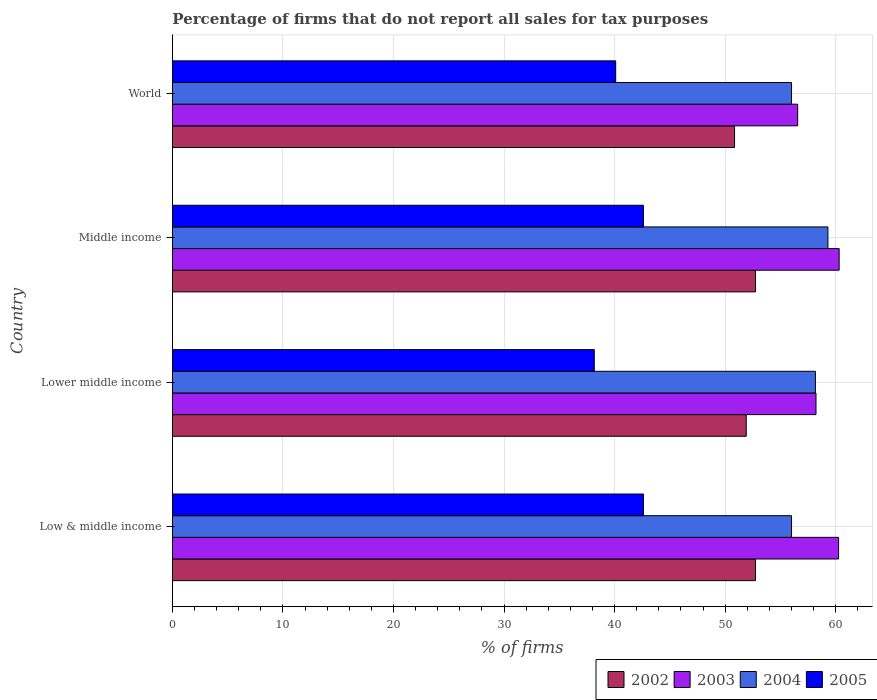How many different coloured bars are there?
Ensure brevity in your answer.  4. Are the number of bars per tick equal to the number of legend labels?
Your answer should be compact. Yes. Are the number of bars on each tick of the Y-axis equal?
Your answer should be very brief. Yes. How many bars are there on the 4th tick from the top?
Offer a very short reply. 4. How many bars are there on the 1st tick from the bottom?
Offer a terse response. 4. What is the label of the 2nd group of bars from the top?
Keep it short and to the point. Middle income. What is the percentage of firms that do not report all sales for tax purposes in 2003 in Low & middle income?
Ensure brevity in your answer.  60.26. Across all countries, what is the maximum percentage of firms that do not report all sales for tax purposes in 2003?
Offer a very short reply. 60.31. Across all countries, what is the minimum percentage of firms that do not report all sales for tax purposes in 2003?
Your response must be concise. 56.56. What is the total percentage of firms that do not report all sales for tax purposes in 2002 in the graph?
Ensure brevity in your answer.  208.25. What is the difference between the percentage of firms that do not report all sales for tax purposes in 2003 in Lower middle income and that in Middle income?
Offer a very short reply. -2.09. What is the difference between the percentage of firms that do not report all sales for tax purposes in 2003 in Middle income and the percentage of firms that do not report all sales for tax purposes in 2005 in Low & middle income?
Provide a short and direct response. 17.7. What is the average percentage of firms that do not report all sales for tax purposes in 2002 per country?
Your answer should be compact. 52.06. What is the difference between the percentage of firms that do not report all sales for tax purposes in 2002 and percentage of firms that do not report all sales for tax purposes in 2003 in World?
Your answer should be compact. -5.71. In how many countries, is the percentage of firms that do not report all sales for tax purposes in 2004 greater than 50 %?
Your answer should be very brief. 4. What is the ratio of the percentage of firms that do not report all sales for tax purposes in 2004 in Low & middle income to that in Lower middle income?
Make the answer very short. 0.96. Is the difference between the percentage of firms that do not report all sales for tax purposes in 2002 in Lower middle income and Middle income greater than the difference between the percentage of firms that do not report all sales for tax purposes in 2003 in Lower middle income and Middle income?
Ensure brevity in your answer.  Yes. What is the difference between the highest and the second highest percentage of firms that do not report all sales for tax purposes in 2004?
Give a very brief answer. 1.13. What is the difference between the highest and the lowest percentage of firms that do not report all sales for tax purposes in 2004?
Your answer should be very brief. 3.29. Is it the case that in every country, the sum of the percentage of firms that do not report all sales for tax purposes in 2003 and percentage of firms that do not report all sales for tax purposes in 2002 is greater than the sum of percentage of firms that do not report all sales for tax purposes in 2004 and percentage of firms that do not report all sales for tax purposes in 2005?
Offer a very short reply. No. What does the 2nd bar from the top in World represents?
Provide a short and direct response. 2004. Are all the bars in the graph horizontal?
Make the answer very short. Yes. What is the difference between two consecutive major ticks on the X-axis?
Your response must be concise. 10. Are the values on the major ticks of X-axis written in scientific E-notation?
Offer a terse response. No. Does the graph contain any zero values?
Provide a succinct answer. No. Does the graph contain grids?
Offer a terse response. Yes. Where does the legend appear in the graph?
Give a very brief answer. Bottom right. What is the title of the graph?
Ensure brevity in your answer.  Percentage of firms that do not report all sales for tax purposes. Does "1982" appear as one of the legend labels in the graph?
Your answer should be compact. No. What is the label or title of the X-axis?
Ensure brevity in your answer.  % of firms. What is the % of firms in 2002 in Low & middle income?
Make the answer very short. 52.75. What is the % of firms in 2003 in Low & middle income?
Your response must be concise. 60.26. What is the % of firms in 2004 in Low & middle income?
Your answer should be compact. 56.01. What is the % of firms of 2005 in Low & middle income?
Ensure brevity in your answer.  42.61. What is the % of firms of 2002 in Lower middle income?
Offer a very short reply. 51.91. What is the % of firms in 2003 in Lower middle income?
Offer a terse response. 58.22. What is the % of firms in 2004 in Lower middle income?
Offer a terse response. 58.16. What is the % of firms of 2005 in Lower middle income?
Provide a succinct answer. 38.16. What is the % of firms of 2002 in Middle income?
Keep it short and to the point. 52.75. What is the % of firms of 2003 in Middle income?
Your response must be concise. 60.31. What is the % of firms in 2004 in Middle income?
Your answer should be compact. 59.3. What is the % of firms of 2005 in Middle income?
Provide a short and direct response. 42.61. What is the % of firms in 2002 in World?
Make the answer very short. 50.85. What is the % of firms in 2003 in World?
Make the answer very short. 56.56. What is the % of firms in 2004 in World?
Provide a short and direct response. 56.01. What is the % of firms in 2005 in World?
Keep it short and to the point. 40.1. Across all countries, what is the maximum % of firms in 2002?
Offer a terse response. 52.75. Across all countries, what is the maximum % of firms of 2003?
Provide a short and direct response. 60.31. Across all countries, what is the maximum % of firms in 2004?
Offer a very short reply. 59.3. Across all countries, what is the maximum % of firms of 2005?
Ensure brevity in your answer.  42.61. Across all countries, what is the minimum % of firms of 2002?
Your answer should be compact. 50.85. Across all countries, what is the minimum % of firms of 2003?
Offer a very short reply. 56.56. Across all countries, what is the minimum % of firms of 2004?
Make the answer very short. 56.01. Across all countries, what is the minimum % of firms in 2005?
Offer a terse response. 38.16. What is the total % of firms of 2002 in the graph?
Ensure brevity in your answer.  208.25. What is the total % of firms in 2003 in the graph?
Your answer should be very brief. 235.35. What is the total % of firms in 2004 in the graph?
Offer a terse response. 229.47. What is the total % of firms in 2005 in the graph?
Keep it short and to the point. 163.48. What is the difference between the % of firms in 2002 in Low & middle income and that in Lower middle income?
Provide a short and direct response. 0.84. What is the difference between the % of firms of 2003 in Low & middle income and that in Lower middle income?
Offer a very short reply. 2.04. What is the difference between the % of firms in 2004 in Low & middle income and that in Lower middle income?
Provide a succinct answer. -2.16. What is the difference between the % of firms in 2005 in Low & middle income and that in Lower middle income?
Offer a very short reply. 4.45. What is the difference between the % of firms of 2002 in Low & middle income and that in Middle income?
Ensure brevity in your answer.  0. What is the difference between the % of firms in 2003 in Low & middle income and that in Middle income?
Your answer should be very brief. -0.05. What is the difference between the % of firms in 2004 in Low & middle income and that in Middle income?
Provide a succinct answer. -3.29. What is the difference between the % of firms in 2005 in Low & middle income and that in Middle income?
Your answer should be very brief. 0. What is the difference between the % of firms of 2002 in Low & middle income and that in World?
Your answer should be very brief. 1.89. What is the difference between the % of firms in 2005 in Low & middle income and that in World?
Ensure brevity in your answer.  2.51. What is the difference between the % of firms of 2002 in Lower middle income and that in Middle income?
Keep it short and to the point. -0.84. What is the difference between the % of firms in 2003 in Lower middle income and that in Middle income?
Your answer should be compact. -2.09. What is the difference between the % of firms in 2004 in Lower middle income and that in Middle income?
Ensure brevity in your answer.  -1.13. What is the difference between the % of firms of 2005 in Lower middle income and that in Middle income?
Provide a short and direct response. -4.45. What is the difference between the % of firms of 2002 in Lower middle income and that in World?
Your answer should be very brief. 1.06. What is the difference between the % of firms of 2003 in Lower middle income and that in World?
Provide a short and direct response. 1.66. What is the difference between the % of firms of 2004 in Lower middle income and that in World?
Your answer should be compact. 2.16. What is the difference between the % of firms of 2005 in Lower middle income and that in World?
Provide a succinct answer. -1.94. What is the difference between the % of firms of 2002 in Middle income and that in World?
Offer a terse response. 1.89. What is the difference between the % of firms of 2003 in Middle income and that in World?
Ensure brevity in your answer.  3.75. What is the difference between the % of firms in 2004 in Middle income and that in World?
Offer a very short reply. 3.29. What is the difference between the % of firms of 2005 in Middle income and that in World?
Offer a very short reply. 2.51. What is the difference between the % of firms in 2002 in Low & middle income and the % of firms in 2003 in Lower middle income?
Ensure brevity in your answer.  -5.47. What is the difference between the % of firms of 2002 in Low & middle income and the % of firms of 2004 in Lower middle income?
Offer a very short reply. -5.42. What is the difference between the % of firms of 2002 in Low & middle income and the % of firms of 2005 in Lower middle income?
Your answer should be very brief. 14.58. What is the difference between the % of firms in 2003 in Low & middle income and the % of firms in 2004 in Lower middle income?
Your answer should be compact. 2.1. What is the difference between the % of firms in 2003 in Low & middle income and the % of firms in 2005 in Lower middle income?
Provide a short and direct response. 22.1. What is the difference between the % of firms of 2004 in Low & middle income and the % of firms of 2005 in Lower middle income?
Your answer should be very brief. 17.84. What is the difference between the % of firms in 2002 in Low & middle income and the % of firms in 2003 in Middle income?
Offer a very short reply. -7.57. What is the difference between the % of firms in 2002 in Low & middle income and the % of firms in 2004 in Middle income?
Provide a succinct answer. -6.55. What is the difference between the % of firms in 2002 in Low & middle income and the % of firms in 2005 in Middle income?
Offer a terse response. 10.13. What is the difference between the % of firms in 2003 in Low & middle income and the % of firms in 2005 in Middle income?
Keep it short and to the point. 17.65. What is the difference between the % of firms in 2004 in Low & middle income and the % of firms in 2005 in Middle income?
Give a very brief answer. 13.39. What is the difference between the % of firms in 2002 in Low & middle income and the % of firms in 2003 in World?
Offer a terse response. -3.81. What is the difference between the % of firms of 2002 in Low & middle income and the % of firms of 2004 in World?
Your answer should be compact. -3.26. What is the difference between the % of firms in 2002 in Low & middle income and the % of firms in 2005 in World?
Your response must be concise. 12.65. What is the difference between the % of firms of 2003 in Low & middle income and the % of firms of 2004 in World?
Ensure brevity in your answer.  4.25. What is the difference between the % of firms in 2003 in Low & middle income and the % of firms in 2005 in World?
Offer a terse response. 20.16. What is the difference between the % of firms of 2004 in Low & middle income and the % of firms of 2005 in World?
Make the answer very short. 15.91. What is the difference between the % of firms of 2002 in Lower middle income and the % of firms of 2003 in Middle income?
Ensure brevity in your answer.  -8.4. What is the difference between the % of firms of 2002 in Lower middle income and the % of firms of 2004 in Middle income?
Your answer should be compact. -7.39. What is the difference between the % of firms of 2002 in Lower middle income and the % of firms of 2005 in Middle income?
Provide a succinct answer. 9.3. What is the difference between the % of firms in 2003 in Lower middle income and the % of firms in 2004 in Middle income?
Keep it short and to the point. -1.08. What is the difference between the % of firms in 2003 in Lower middle income and the % of firms in 2005 in Middle income?
Provide a short and direct response. 15.61. What is the difference between the % of firms of 2004 in Lower middle income and the % of firms of 2005 in Middle income?
Offer a very short reply. 15.55. What is the difference between the % of firms of 2002 in Lower middle income and the % of firms of 2003 in World?
Keep it short and to the point. -4.65. What is the difference between the % of firms in 2002 in Lower middle income and the % of firms in 2004 in World?
Ensure brevity in your answer.  -4.1. What is the difference between the % of firms in 2002 in Lower middle income and the % of firms in 2005 in World?
Offer a very short reply. 11.81. What is the difference between the % of firms of 2003 in Lower middle income and the % of firms of 2004 in World?
Your response must be concise. 2.21. What is the difference between the % of firms of 2003 in Lower middle income and the % of firms of 2005 in World?
Ensure brevity in your answer.  18.12. What is the difference between the % of firms in 2004 in Lower middle income and the % of firms in 2005 in World?
Offer a very short reply. 18.07. What is the difference between the % of firms in 2002 in Middle income and the % of firms in 2003 in World?
Offer a very short reply. -3.81. What is the difference between the % of firms in 2002 in Middle income and the % of firms in 2004 in World?
Give a very brief answer. -3.26. What is the difference between the % of firms in 2002 in Middle income and the % of firms in 2005 in World?
Give a very brief answer. 12.65. What is the difference between the % of firms of 2003 in Middle income and the % of firms of 2004 in World?
Your answer should be very brief. 4.31. What is the difference between the % of firms in 2003 in Middle income and the % of firms in 2005 in World?
Make the answer very short. 20.21. What is the difference between the % of firms of 2004 in Middle income and the % of firms of 2005 in World?
Your answer should be very brief. 19.2. What is the average % of firms of 2002 per country?
Provide a succinct answer. 52.06. What is the average % of firms in 2003 per country?
Offer a very short reply. 58.84. What is the average % of firms of 2004 per country?
Keep it short and to the point. 57.37. What is the average % of firms of 2005 per country?
Ensure brevity in your answer.  40.87. What is the difference between the % of firms of 2002 and % of firms of 2003 in Low & middle income?
Make the answer very short. -7.51. What is the difference between the % of firms of 2002 and % of firms of 2004 in Low & middle income?
Make the answer very short. -3.26. What is the difference between the % of firms of 2002 and % of firms of 2005 in Low & middle income?
Your response must be concise. 10.13. What is the difference between the % of firms of 2003 and % of firms of 2004 in Low & middle income?
Ensure brevity in your answer.  4.25. What is the difference between the % of firms of 2003 and % of firms of 2005 in Low & middle income?
Your response must be concise. 17.65. What is the difference between the % of firms in 2004 and % of firms in 2005 in Low & middle income?
Provide a short and direct response. 13.39. What is the difference between the % of firms of 2002 and % of firms of 2003 in Lower middle income?
Provide a succinct answer. -6.31. What is the difference between the % of firms of 2002 and % of firms of 2004 in Lower middle income?
Ensure brevity in your answer.  -6.26. What is the difference between the % of firms in 2002 and % of firms in 2005 in Lower middle income?
Provide a short and direct response. 13.75. What is the difference between the % of firms in 2003 and % of firms in 2004 in Lower middle income?
Offer a very short reply. 0.05. What is the difference between the % of firms in 2003 and % of firms in 2005 in Lower middle income?
Provide a short and direct response. 20.06. What is the difference between the % of firms of 2004 and % of firms of 2005 in Lower middle income?
Provide a succinct answer. 20. What is the difference between the % of firms in 2002 and % of firms in 2003 in Middle income?
Ensure brevity in your answer.  -7.57. What is the difference between the % of firms of 2002 and % of firms of 2004 in Middle income?
Make the answer very short. -6.55. What is the difference between the % of firms of 2002 and % of firms of 2005 in Middle income?
Ensure brevity in your answer.  10.13. What is the difference between the % of firms of 2003 and % of firms of 2004 in Middle income?
Provide a short and direct response. 1.02. What is the difference between the % of firms of 2003 and % of firms of 2005 in Middle income?
Keep it short and to the point. 17.7. What is the difference between the % of firms of 2004 and % of firms of 2005 in Middle income?
Make the answer very short. 16.69. What is the difference between the % of firms in 2002 and % of firms in 2003 in World?
Provide a succinct answer. -5.71. What is the difference between the % of firms of 2002 and % of firms of 2004 in World?
Your answer should be compact. -5.15. What is the difference between the % of firms in 2002 and % of firms in 2005 in World?
Provide a short and direct response. 10.75. What is the difference between the % of firms of 2003 and % of firms of 2004 in World?
Give a very brief answer. 0.56. What is the difference between the % of firms in 2003 and % of firms in 2005 in World?
Provide a short and direct response. 16.46. What is the difference between the % of firms of 2004 and % of firms of 2005 in World?
Keep it short and to the point. 15.91. What is the ratio of the % of firms in 2002 in Low & middle income to that in Lower middle income?
Offer a terse response. 1.02. What is the ratio of the % of firms of 2003 in Low & middle income to that in Lower middle income?
Your answer should be compact. 1.04. What is the ratio of the % of firms of 2004 in Low & middle income to that in Lower middle income?
Your response must be concise. 0.96. What is the ratio of the % of firms in 2005 in Low & middle income to that in Lower middle income?
Give a very brief answer. 1.12. What is the ratio of the % of firms of 2002 in Low & middle income to that in Middle income?
Keep it short and to the point. 1. What is the ratio of the % of firms in 2003 in Low & middle income to that in Middle income?
Ensure brevity in your answer.  1. What is the ratio of the % of firms of 2004 in Low & middle income to that in Middle income?
Your response must be concise. 0.94. What is the ratio of the % of firms in 2002 in Low & middle income to that in World?
Offer a terse response. 1.04. What is the ratio of the % of firms in 2003 in Low & middle income to that in World?
Provide a short and direct response. 1.07. What is the ratio of the % of firms in 2004 in Low & middle income to that in World?
Provide a succinct answer. 1. What is the ratio of the % of firms in 2005 in Low & middle income to that in World?
Your answer should be compact. 1.06. What is the ratio of the % of firms of 2002 in Lower middle income to that in Middle income?
Offer a terse response. 0.98. What is the ratio of the % of firms in 2003 in Lower middle income to that in Middle income?
Offer a very short reply. 0.97. What is the ratio of the % of firms of 2004 in Lower middle income to that in Middle income?
Your answer should be very brief. 0.98. What is the ratio of the % of firms in 2005 in Lower middle income to that in Middle income?
Provide a short and direct response. 0.9. What is the ratio of the % of firms of 2002 in Lower middle income to that in World?
Your answer should be compact. 1.02. What is the ratio of the % of firms in 2003 in Lower middle income to that in World?
Keep it short and to the point. 1.03. What is the ratio of the % of firms of 2004 in Lower middle income to that in World?
Ensure brevity in your answer.  1.04. What is the ratio of the % of firms of 2005 in Lower middle income to that in World?
Your answer should be compact. 0.95. What is the ratio of the % of firms of 2002 in Middle income to that in World?
Keep it short and to the point. 1.04. What is the ratio of the % of firms in 2003 in Middle income to that in World?
Ensure brevity in your answer.  1.07. What is the ratio of the % of firms in 2004 in Middle income to that in World?
Ensure brevity in your answer.  1.06. What is the ratio of the % of firms of 2005 in Middle income to that in World?
Provide a short and direct response. 1.06. What is the difference between the highest and the second highest % of firms of 2003?
Offer a very short reply. 0.05. What is the difference between the highest and the second highest % of firms in 2004?
Your answer should be compact. 1.13. What is the difference between the highest and the lowest % of firms in 2002?
Ensure brevity in your answer.  1.89. What is the difference between the highest and the lowest % of firms of 2003?
Offer a very short reply. 3.75. What is the difference between the highest and the lowest % of firms in 2004?
Provide a succinct answer. 3.29. What is the difference between the highest and the lowest % of firms in 2005?
Provide a short and direct response. 4.45. 